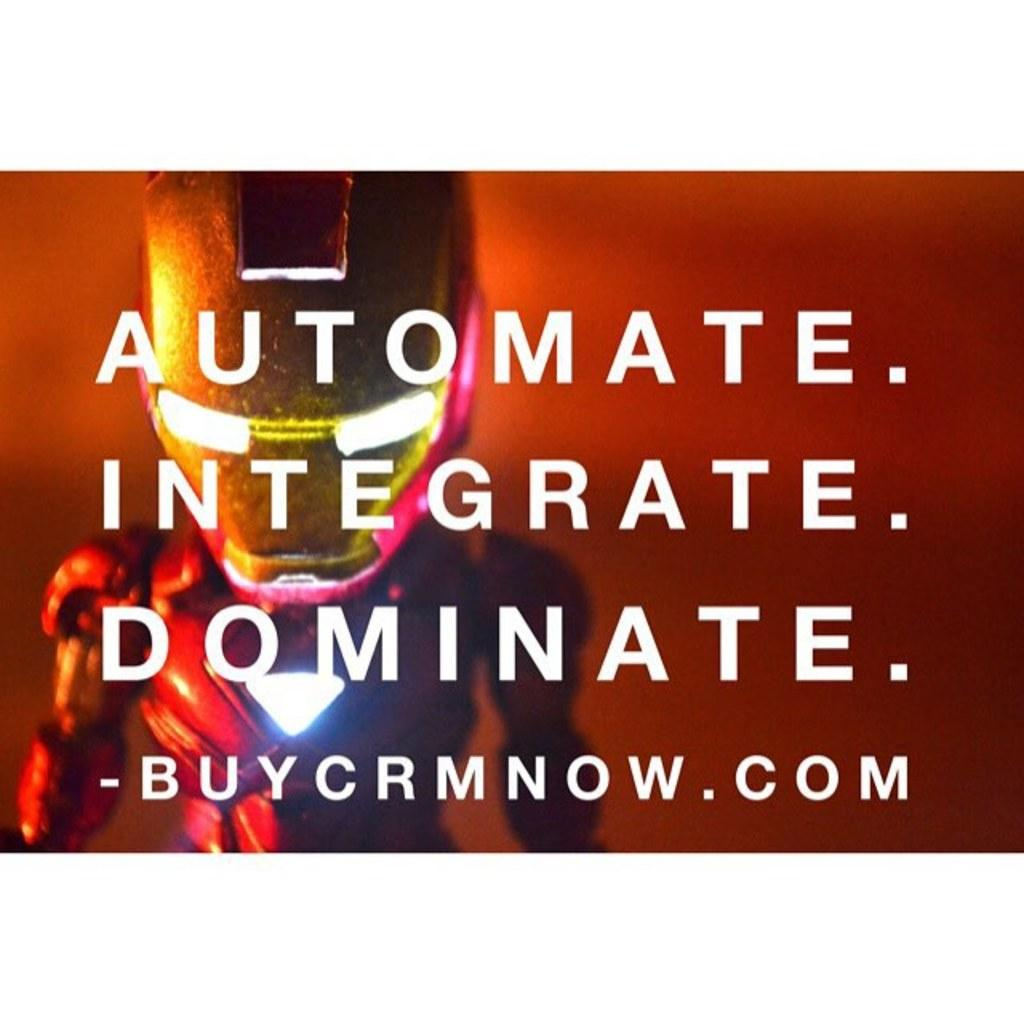Provide a one-sentence caption for the provided image. Ad that says to Automate, Integrate, and Dominate. 